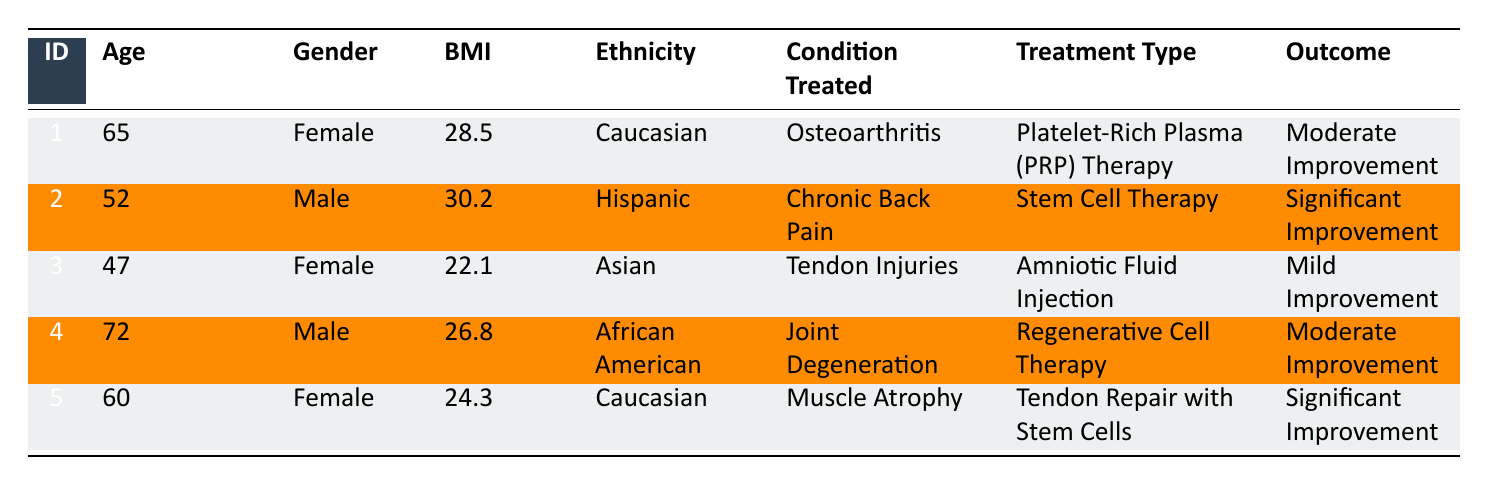What is the treatment type for PatientID 2? By looking at the row for PatientID 2 in the table, the treatment type listed is "Stem Cell Therapy".
Answer: Stem Cell Therapy What is the outcome for the patient with the highest BMI? PatientID 2 has the highest BMI of 30.2, and according to the table, the outcome for this patient is "Significant Improvement".
Answer: Significant Improvement Is there any patient with a "Mild Improvement" outcome? Yes, by checking the outcomes in the table, PatientID 3 has an outcome of "Mild Improvement".
Answer: Yes Which gender has the patient with the lowest age? PatientID 3 is the youngest at 47 years old, and this patient is female.
Answer: Female What is the average age of all patients? To find the average age, we sum the ages: 65 + 52 + 47 + 72 + 60 = 296. There are 5 patients, so the average age is 296/5 = 59.2.
Answer: 59.2 Do all patients receive significant improvement from their treatments? No, by reviewing the outcomes, only Patients 2 and 5 received "Significant Improvement". The other patients had either "Moderate Improvement" or "Mild Improvement".
Answer: No Which treatment type has a moderate improvement outcome? PatientID 1 and PatientID 4 both have "Moderate Improvement" outcomes for their respective treatment types, which are "Platelet-Rich Plasma (PRP) Therapy" and "Regenerative Cell Therapy".
Answer: Platelet-Rich Plasma (PRP) Therapy, Regenerative Cell Therapy What percentage of patients receive significant improvement? Out of 5 patients, 2 received "Significant Improvement". Therefore, the percentage is (2/5) * 100 = 40%.
Answer: 40% How many months did PatientID 5 follow up after their treatment? The table indicates that PatientID 5 had a follow-up period of 10 months after the "Tendon Repair with Stem Cells" treatment.
Answer: 10 months 